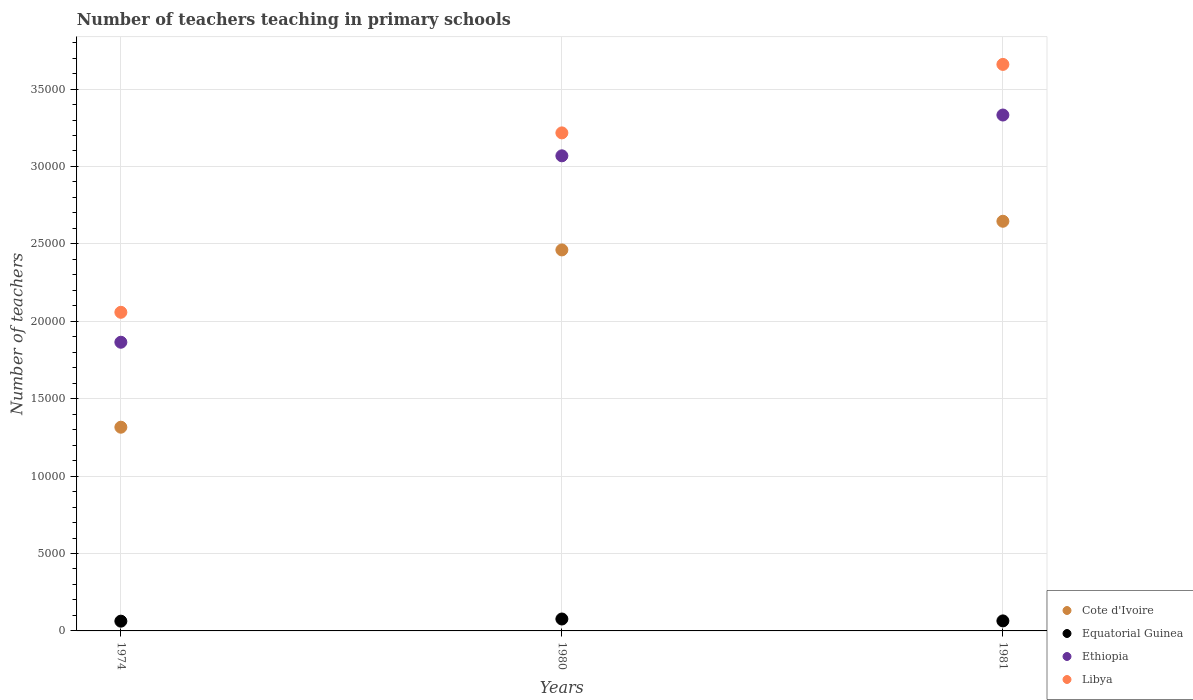How many different coloured dotlines are there?
Ensure brevity in your answer.  4. Is the number of dotlines equal to the number of legend labels?
Offer a very short reply. Yes. What is the number of teachers teaching in primary schools in Cote d'Ivoire in 1974?
Provide a short and direct response. 1.32e+04. Across all years, what is the maximum number of teachers teaching in primary schools in Equatorial Guinea?
Ensure brevity in your answer.  770. Across all years, what is the minimum number of teachers teaching in primary schools in Libya?
Ensure brevity in your answer.  2.06e+04. In which year was the number of teachers teaching in primary schools in Libya minimum?
Provide a short and direct response. 1974. What is the total number of teachers teaching in primary schools in Cote d'Ivoire in the graph?
Offer a terse response. 6.42e+04. What is the difference between the number of teachers teaching in primary schools in Ethiopia in 1980 and that in 1981?
Provide a short and direct response. -2635. What is the difference between the number of teachers teaching in primary schools in Cote d'Ivoire in 1981 and the number of teachers teaching in primary schools in Ethiopia in 1974?
Provide a short and direct response. 7814. What is the average number of teachers teaching in primary schools in Equatorial Guinea per year?
Make the answer very short. 682.33. In the year 1974, what is the difference between the number of teachers teaching in primary schools in Equatorial Guinea and number of teachers teaching in primary schools in Cote d'Ivoire?
Your answer should be very brief. -1.25e+04. In how many years, is the number of teachers teaching in primary schools in Libya greater than 28000?
Give a very brief answer. 2. What is the ratio of the number of teachers teaching in primary schools in Equatorial Guinea in 1974 to that in 1981?
Your answer should be very brief. 0.97. Is the number of teachers teaching in primary schools in Equatorial Guinea in 1974 less than that in 1981?
Make the answer very short. Yes. What is the difference between the highest and the second highest number of teachers teaching in primary schools in Libya?
Offer a terse response. 4423. What is the difference between the highest and the lowest number of teachers teaching in primary schools in Libya?
Offer a terse response. 1.60e+04. Does the number of teachers teaching in primary schools in Ethiopia monotonically increase over the years?
Your response must be concise. Yes. Is the number of teachers teaching in primary schools in Ethiopia strictly greater than the number of teachers teaching in primary schools in Libya over the years?
Your answer should be very brief. No. Is the number of teachers teaching in primary schools in Equatorial Guinea strictly less than the number of teachers teaching in primary schools in Ethiopia over the years?
Ensure brevity in your answer.  Yes. How many dotlines are there?
Offer a terse response. 4. Are the values on the major ticks of Y-axis written in scientific E-notation?
Keep it short and to the point. No. Where does the legend appear in the graph?
Your answer should be very brief. Bottom right. How many legend labels are there?
Offer a very short reply. 4. How are the legend labels stacked?
Keep it short and to the point. Vertical. What is the title of the graph?
Keep it short and to the point. Number of teachers teaching in primary schools. What is the label or title of the X-axis?
Make the answer very short. Years. What is the label or title of the Y-axis?
Your response must be concise. Number of teachers. What is the Number of teachers of Cote d'Ivoire in 1974?
Provide a succinct answer. 1.32e+04. What is the Number of teachers of Equatorial Guinea in 1974?
Offer a very short reply. 630. What is the Number of teachers in Ethiopia in 1974?
Offer a terse response. 1.86e+04. What is the Number of teachers in Libya in 1974?
Ensure brevity in your answer.  2.06e+04. What is the Number of teachers of Cote d'Ivoire in 1980?
Make the answer very short. 2.46e+04. What is the Number of teachers in Equatorial Guinea in 1980?
Make the answer very short. 770. What is the Number of teachers of Ethiopia in 1980?
Give a very brief answer. 3.07e+04. What is the Number of teachers in Libya in 1980?
Your answer should be compact. 3.22e+04. What is the Number of teachers in Cote d'Ivoire in 1981?
Provide a succinct answer. 2.65e+04. What is the Number of teachers of Equatorial Guinea in 1981?
Offer a terse response. 647. What is the Number of teachers in Ethiopia in 1981?
Your response must be concise. 3.33e+04. What is the Number of teachers of Libya in 1981?
Offer a terse response. 3.66e+04. Across all years, what is the maximum Number of teachers in Cote d'Ivoire?
Your answer should be very brief. 2.65e+04. Across all years, what is the maximum Number of teachers of Equatorial Guinea?
Your answer should be very brief. 770. Across all years, what is the maximum Number of teachers of Ethiopia?
Provide a succinct answer. 3.33e+04. Across all years, what is the maximum Number of teachers in Libya?
Make the answer very short. 3.66e+04. Across all years, what is the minimum Number of teachers of Cote d'Ivoire?
Your response must be concise. 1.32e+04. Across all years, what is the minimum Number of teachers in Equatorial Guinea?
Offer a terse response. 630. Across all years, what is the minimum Number of teachers of Ethiopia?
Your answer should be compact. 1.86e+04. Across all years, what is the minimum Number of teachers of Libya?
Provide a succinct answer. 2.06e+04. What is the total Number of teachers in Cote d'Ivoire in the graph?
Offer a very short reply. 6.42e+04. What is the total Number of teachers of Equatorial Guinea in the graph?
Offer a terse response. 2047. What is the total Number of teachers of Ethiopia in the graph?
Keep it short and to the point. 8.27e+04. What is the total Number of teachers of Libya in the graph?
Provide a short and direct response. 8.93e+04. What is the difference between the Number of teachers in Cote d'Ivoire in 1974 and that in 1980?
Ensure brevity in your answer.  -1.15e+04. What is the difference between the Number of teachers in Equatorial Guinea in 1974 and that in 1980?
Make the answer very short. -140. What is the difference between the Number of teachers in Ethiopia in 1974 and that in 1980?
Make the answer very short. -1.20e+04. What is the difference between the Number of teachers of Libya in 1974 and that in 1980?
Provide a short and direct response. -1.16e+04. What is the difference between the Number of teachers in Cote d'Ivoire in 1974 and that in 1981?
Keep it short and to the point. -1.33e+04. What is the difference between the Number of teachers of Equatorial Guinea in 1974 and that in 1981?
Keep it short and to the point. -17. What is the difference between the Number of teachers in Ethiopia in 1974 and that in 1981?
Your response must be concise. -1.47e+04. What is the difference between the Number of teachers in Libya in 1974 and that in 1981?
Your answer should be very brief. -1.60e+04. What is the difference between the Number of teachers of Cote d'Ivoire in 1980 and that in 1981?
Make the answer very short. -1851. What is the difference between the Number of teachers in Equatorial Guinea in 1980 and that in 1981?
Your answer should be compact. 123. What is the difference between the Number of teachers of Ethiopia in 1980 and that in 1981?
Offer a very short reply. -2635. What is the difference between the Number of teachers of Libya in 1980 and that in 1981?
Ensure brevity in your answer.  -4423. What is the difference between the Number of teachers of Cote d'Ivoire in 1974 and the Number of teachers of Equatorial Guinea in 1980?
Your answer should be very brief. 1.24e+04. What is the difference between the Number of teachers in Cote d'Ivoire in 1974 and the Number of teachers in Ethiopia in 1980?
Offer a terse response. -1.75e+04. What is the difference between the Number of teachers in Cote d'Ivoire in 1974 and the Number of teachers in Libya in 1980?
Provide a short and direct response. -1.90e+04. What is the difference between the Number of teachers in Equatorial Guinea in 1974 and the Number of teachers in Ethiopia in 1980?
Give a very brief answer. -3.01e+04. What is the difference between the Number of teachers in Equatorial Guinea in 1974 and the Number of teachers in Libya in 1980?
Keep it short and to the point. -3.15e+04. What is the difference between the Number of teachers in Ethiopia in 1974 and the Number of teachers in Libya in 1980?
Keep it short and to the point. -1.35e+04. What is the difference between the Number of teachers in Cote d'Ivoire in 1974 and the Number of teachers in Equatorial Guinea in 1981?
Your answer should be very brief. 1.25e+04. What is the difference between the Number of teachers of Cote d'Ivoire in 1974 and the Number of teachers of Ethiopia in 1981?
Make the answer very short. -2.02e+04. What is the difference between the Number of teachers of Cote d'Ivoire in 1974 and the Number of teachers of Libya in 1981?
Your response must be concise. -2.34e+04. What is the difference between the Number of teachers of Equatorial Guinea in 1974 and the Number of teachers of Ethiopia in 1981?
Provide a succinct answer. -3.27e+04. What is the difference between the Number of teachers in Equatorial Guinea in 1974 and the Number of teachers in Libya in 1981?
Your answer should be very brief. -3.60e+04. What is the difference between the Number of teachers in Ethiopia in 1974 and the Number of teachers in Libya in 1981?
Provide a succinct answer. -1.79e+04. What is the difference between the Number of teachers of Cote d'Ivoire in 1980 and the Number of teachers of Equatorial Guinea in 1981?
Give a very brief answer. 2.40e+04. What is the difference between the Number of teachers of Cote d'Ivoire in 1980 and the Number of teachers of Ethiopia in 1981?
Provide a short and direct response. -8713. What is the difference between the Number of teachers in Cote d'Ivoire in 1980 and the Number of teachers in Libya in 1981?
Your answer should be very brief. -1.20e+04. What is the difference between the Number of teachers in Equatorial Guinea in 1980 and the Number of teachers in Ethiopia in 1981?
Offer a terse response. -3.26e+04. What is the difference between the Number of teachers of Equatorial Guinea in 1980 and the Number of teachers of Libya in 1981?
Provide a short and direct response. -3.58e+04. What is the difference between the Number of teachers of Ethiopia in 1980 and the Number of teachers of Libya in 1981?
Offer a very short reply. -5904. What is the average Number of teachers of Cote d'Ivoire per year?
Offer a very short reply. 2.14e+04. What is the average Number of teachers in Equatorial Guinea per year?
Keep it short and to the point. 682.33. What is the average Number of teachers of Ethiopia per year?
Provide a short and direct response. 2.76e+04. What is the average Number of teachers in Libya per year?
Make the answer very short. 2.98e+04. In the year 1974, what is the difference between the Number of teachers in Cote d'Ivoire and Number of teachers in Equatorial Guinea?
Give a very brief answer. 1.25e+04. In the year 1974, what is the difference between the Number of teachers of Cote d'Ivoire and Number of teachers of Ethiopia?
Provide a short and direct response. -5488. In the year 1974, what is the difference between the Number of teachers in Cote d'Ivoire and Number of teachers in Libya?
Your answer should be compact. -7422. In the year 1974, what is the difference between the Number of teachers in Equatorial Guinea and Number of teachers in Ethiopia?
Provide a short and direct response. -1.80e+04. In the year 1974, what is the difference between the Number of teachers of Equatorial Guinea and Number of teachers of Libya?
Keep it short and to the point. -2.00e+04. In the year 1974, what is the difference between the Number of teachers of Ethiopia and Number of teachers of Libya?
Provide a short and direct response. -1934. In the year 1980, what is the difference between the Number of teachers in Cote d'Ivoire and Number of teachers in Equatorial Guinea?
Your answer should be compact. 2.38e+04. In the year 1980, what is the difference between the Number of teachers in Cote d'Ivoire and Number of teachers in Ethiopia?
Your answer should be compact. -6078. In the year 1980, what is the difference between the Number of teachers in Cote d'Ivoire and Number of teachers in Libya?
Your response must be concise. -7559. In the year 1980, what is the difference between the Number of teachers of Equatorial Guinea and Number of teachers of Ethiopia?
Give a very brief answer. -2.99e+04. In the year 1980, what is the difference between the Number of teachers of Equatorial Guinea and Number of teachers of Libya?
Make the answer very short. -3.14e+04. In the year 1980, what is the difference between the Number of teachers of Ethiopia and Number of teachers of Libya?
Provide a short and direct response. -1481. In the year 1981, what is the difference between the Number of teachers of Cote d'Ivoire and Number of teachers of Equatorial Guinea?
Your answer should be compact. 2.58e+04. In the year 1981, what is the difference between the Number of teachers of Cote d'Ivoire and Number of teachers of Ethiopia?
Your answer should be compact. -6862. In the year 1981, what is the difference between the Number of teachers of Cote d'Ivoire and Number of teachers of Libya?
Ensure brevity in your answer.  -1.01e+04. In the year 1981, what is the difference between the Number of teachers in Equatorial Guinea and Number of teachers in Ethiopia?
Offer a terse response. -3.27e+04. In the year 1981, what is the difference between the Number of teachers of Equatorial Guinea and Number of teachers of Libya?
Ensure brevity in your answer.  -3.59e+04. In the year 1981, what is the difference between the Number of teachers in Ethiopia and Number of teachers in Libya?
Offer a very short reply. -3269. What is the ratio of the Number of teachers in Cote d'Ivoire in 1974 to that in 1980?
Provide a short and direct response. 0.53. What is the ratio of the Number of teachers in Equatorial Guinea in 1974 to that in 1980?
Provide a succinct answer. 0.82. What is the ratio of the Number of teachers in Ethiopia in 1974 to that in 1980?
Provide a short and direct response. 0.61. What is the ratio of the Number of teachers of Libya in 1974 to that in 1980?
Your answer should be compact. 0.64. What is the ratio of the Number of teachers of Cote d'Ivoire in 1974 to that in 1981?
Give a very brief answer. 0.5. What is the ratio of the Number of teachers in Equatorial Guinea in 1974 to that in 1981?
Ensure brevity in your answer.  0.97. What is the ratio of the Number of teachers in Ethiopia in 1974 to that in 1981?
Provide a short and direct response. 0.56. What is the ratio of the Number of teachers of Libya in 1974 to that in 1981?
Your response must be concise. 0.56. What is the ratio of the Number of teachers in Equatorial Guinea in 1980 to that in 1981?
Provide a short and direct response. 1.19. What is the ratio of the Number of teachers in Ethiopia in 1980 to that in 1981?
Your answer should be very brief. 0.92. What is the ratio of the Number of teachers of Libya in 1980 to that in 1981?
Offer a terse response. 0.88. What is the difference between the highest and the second highest Number of teachers of Cote d'Ivoire?
Make the answer very short. 1851. What is the difference between the highest and the second highest Number of teachers in Equatorial Guinea?
Ensure brevity in your answer.  123. What is the difference between the highest and the second highest Number of teachers of Ethiopia?
Give a very brief answer. 2635. What is the difference between the highest and the second highest Number of teachers in Libya?
Your answer should be very brief. 4423. What is the difference between the highest and the lowest Number of teachers of Cote d'Ivoire?
Offer a terse response. 1.33e+04. What is the difference between the highest and the lowest Number of teachers of Equatorial Guinea?
Your response must be concise. 140. What is the difference between the highest and the lowest Number of teachers of Ethiopia?
Your response must be concise. 1.47e+04. What is the difference between the highest and the lowest Number of teachers in Libya?
Offer a very short reply. 1.60e+04. 